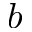Convert formula to latex. <formula><loc_0><loc_0><loc_500><loc_500>b</formula> 